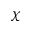Convert formula to latex. <formula><loc_0><loc_0><loc_500><loc_500>\chi</formula> 